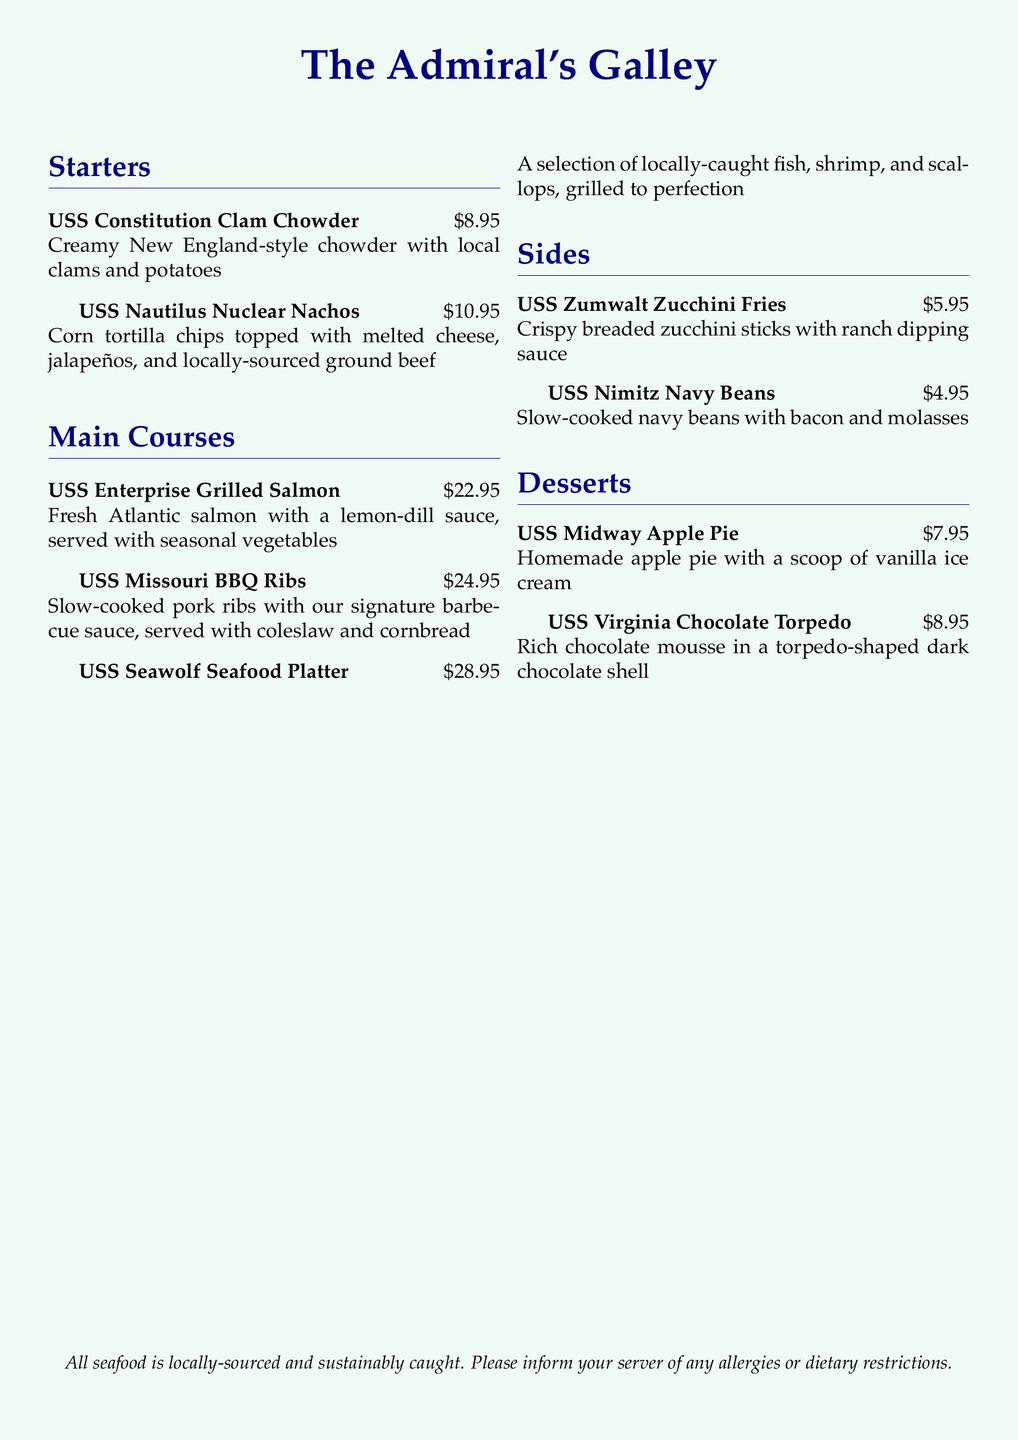What is the price of the USS Constitution Clam Chowder? The price of the USS Constitution Clam Chowder is listed as $8.95 in the document.
Answer: $8.95 What type of sauce is served with the USS Enterprise Grilled Salmon? The USS Enterprise Grilled Salmon is served with a lemon-dill sauce according to the menu description.
Answer: lemon-dill sauce Which dessert comes with a scoop of vanilla ice cream? The menu states that the USS Midway Apple Pie is served with a scoop of vanilla ice cream.
Answer: USS Midway Apple Pie What are the main ingredients in the USS Nautilus Nuclear Nachos? The main ingredients of the USS Nautilus Nuclear Nachos are corn tortilla chips, melted cheese, jalapeños, and locally-sourced ground beef.
Answer: corn tortilla chips, melted cheese, jalapeños, ground beef How much do the USS Missouri BBQ Ribs cost? The USS Missouri BBQ Ribs are priced at $24.95 in the menu.
Answer: $24.95 How many sides are listed on the menu? There are two sides listed on the menu: USS Zumwalt Zucchini Fries and USS Nimitz Navy Beans.
Answer: 2 Which seafood platter features locally-caught fish, shrimp, and scallops? The USS Seawolf Seafood Platter features locally-caught fish, shrimp, and scallops, as mentioned in the document.
Answer: USS Seawolf Seafood Platter What is the total price of the USS Virginia Chocolate Torpedo? The total price for the USS Virginia Chocolate Torpedo is indicated as $8.95 in the menu.
Answer: $8.95 What type of beans are included in the USS Nimitz Navy Beans? The USS Nimitz Navy Beans include navy beans, bacon, and molasses as per the menu description.
Answer: navy beans, bacon, molasses 